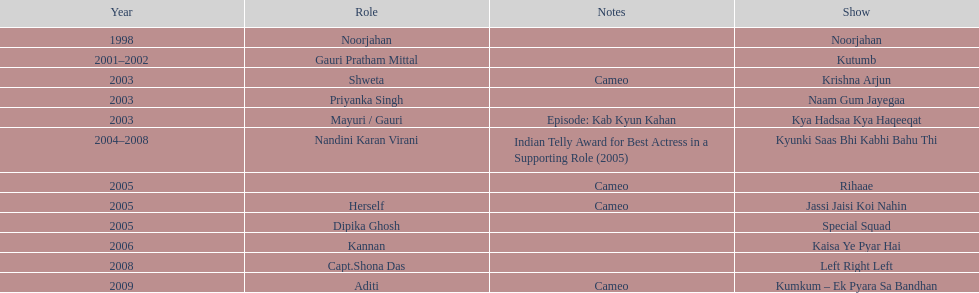The shows with at most 1 cameo Krishna Arjun, Rihaae, Jassi Jaisi Koi Nahin, Kumkum - Ek Pyara Sa Bandhan. 